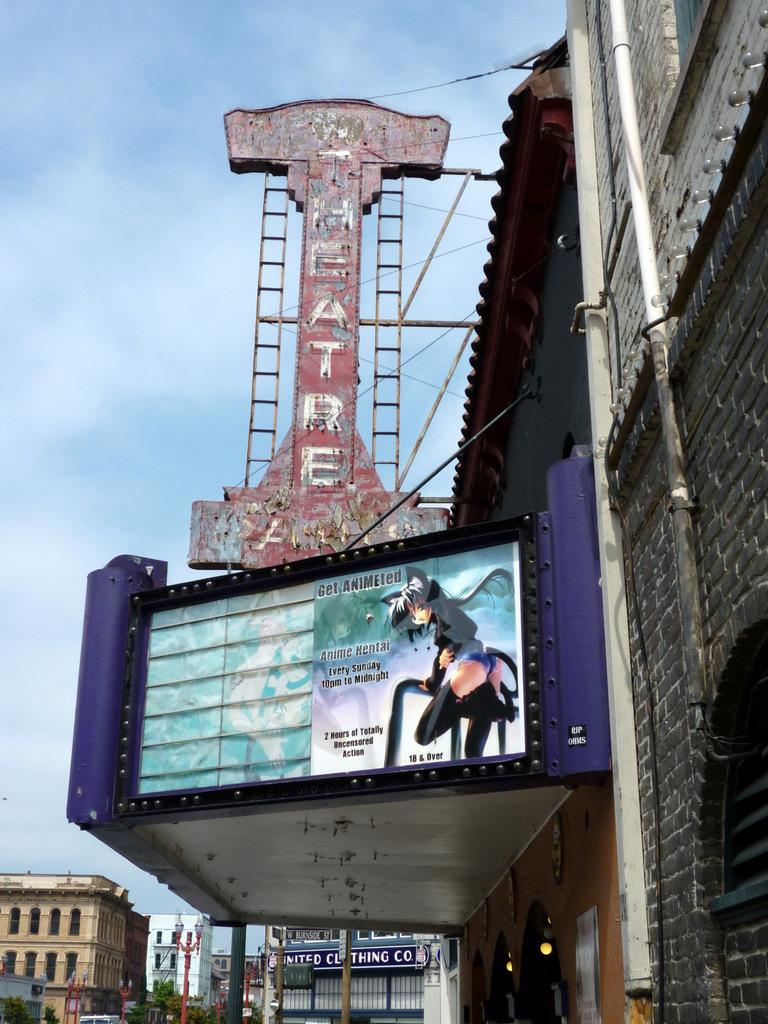<image>
Present a compact description of the photo's key features. An old movie theatre marquee with a poster advertising anime hentai. 